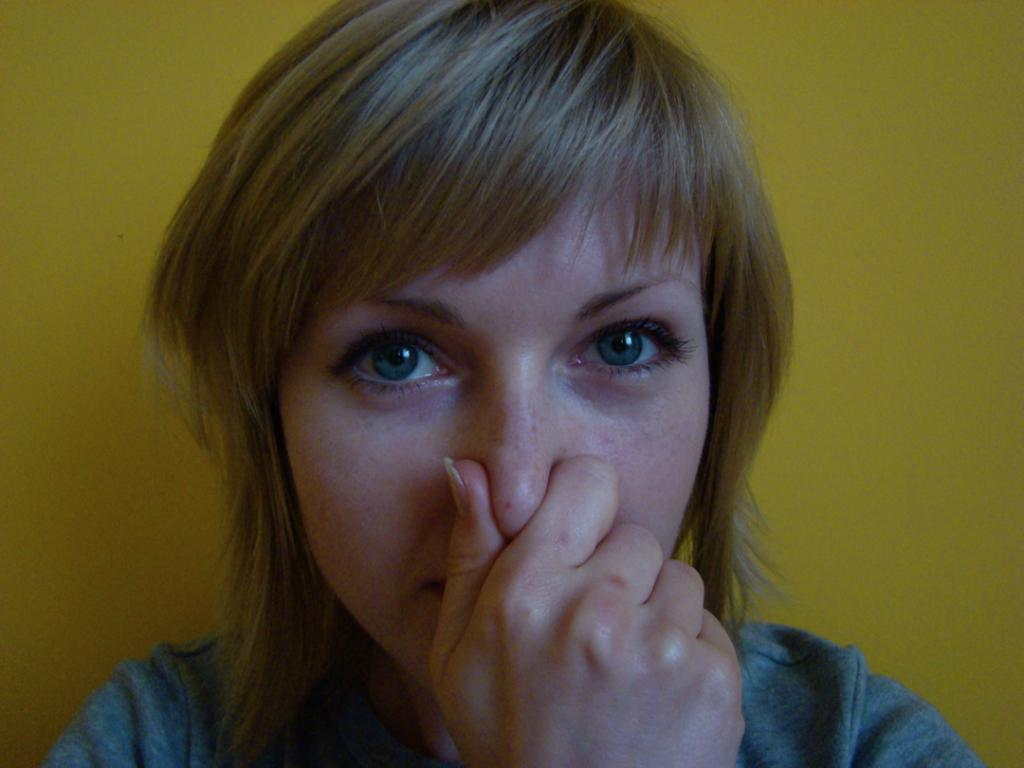What is the main subject of the image? The main subject of the image is a woman. What is the woman doing in the image? The woman is closing her nose with her hand. What type of ship can be seen in the image? There is no ship present in the image; it features a woman closing her nose with her hand. What role does the governor play in the image? There is no governor present in the image, as it only shows a woman closing her nose with her hand. 